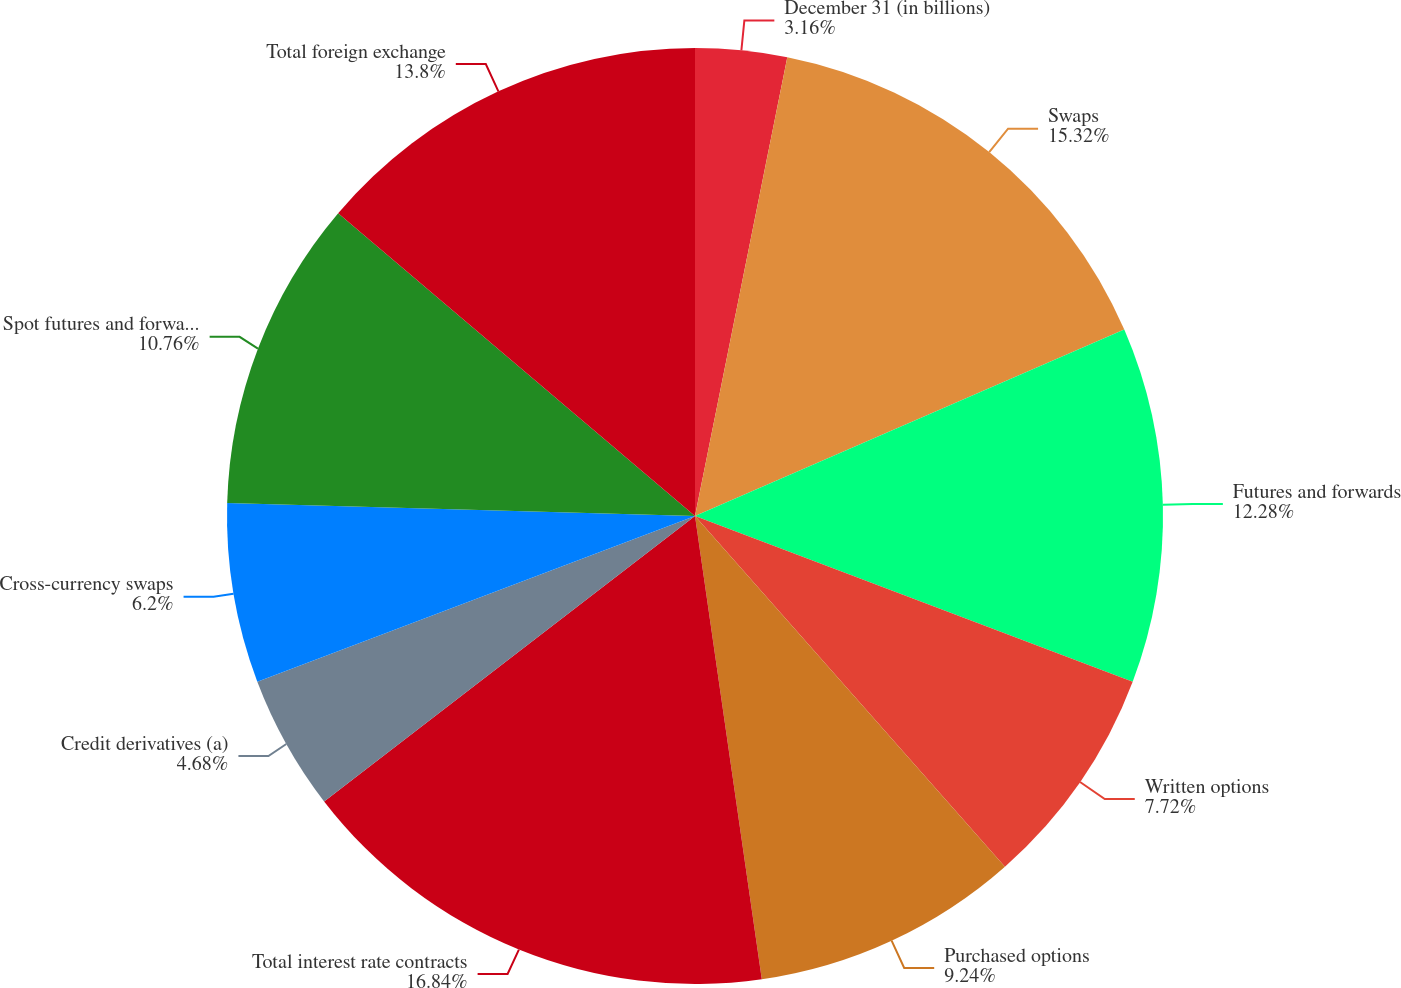Convert chart. <chart><loc_0><loc_0><loc_500><loc_500><pie_chart><fcel>December 31 (in billions)<fcel>Swaps<fcel>Futures and forwards<fcel>Written options<fcel>Purchased options<fcel>Total interest rate contracts<fcel>Credit derivatives (a)<fcel>Cross-currency swaps<fcel>Spot futures and forwards<fcel>Total foreign exchange<nl><fcel>3.16%<fcel>15.32%<fcel>12.28%<fcel>7.72%<fcel>9.24%<fcel>16.84%<fcel>4.68%<fcel>6.2%<fcel>10.76%<fcel>13.8%<nl></chart> 